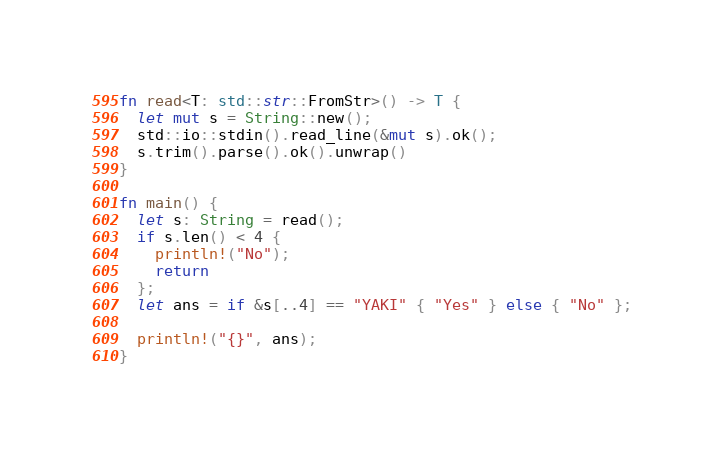<code> <loc_0><loc_0><loc_500><loc_500><_Rust_>fn read<T: std::str::FromStr>() -> T {
  let mut s = String::new();
  std::io::stdin().read_line(&mut s).ok();
  s.trim().parse().ok().unwrap()
}
 
fn main() {
  let s: String = read();
  if s.len() < 4 {
    println!("No");
    return
  };
  let ans = if &s[..4] == "YAKI" { "Yes" } else { "No" };
 
  println!("{}", ans);
}
</code> 